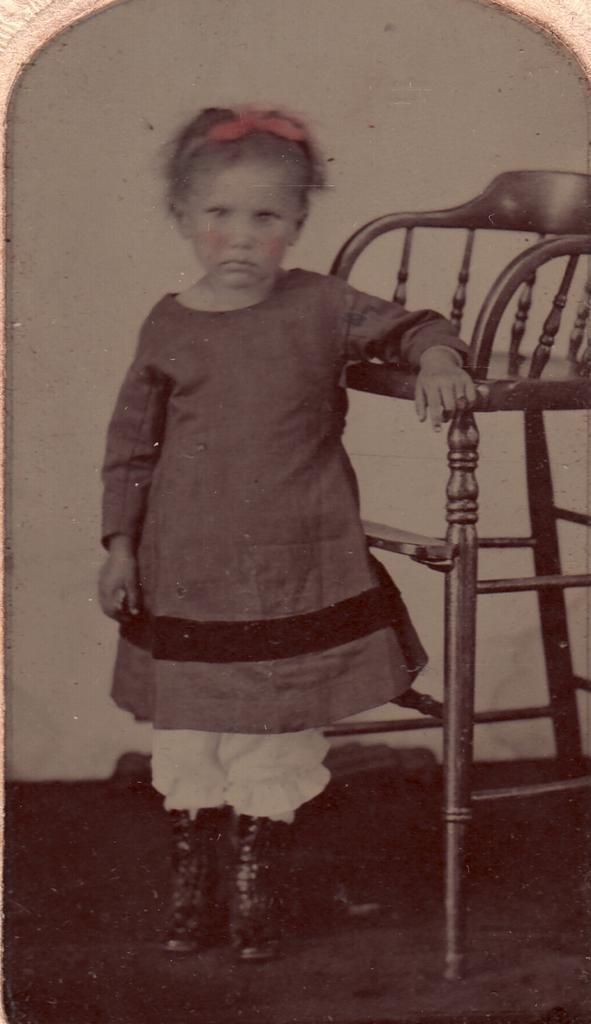How would you summarize this image in a sentence or two? This picture looking like photo we can see this kid standing and we can see chair on the floor. On the background we can see wall. 